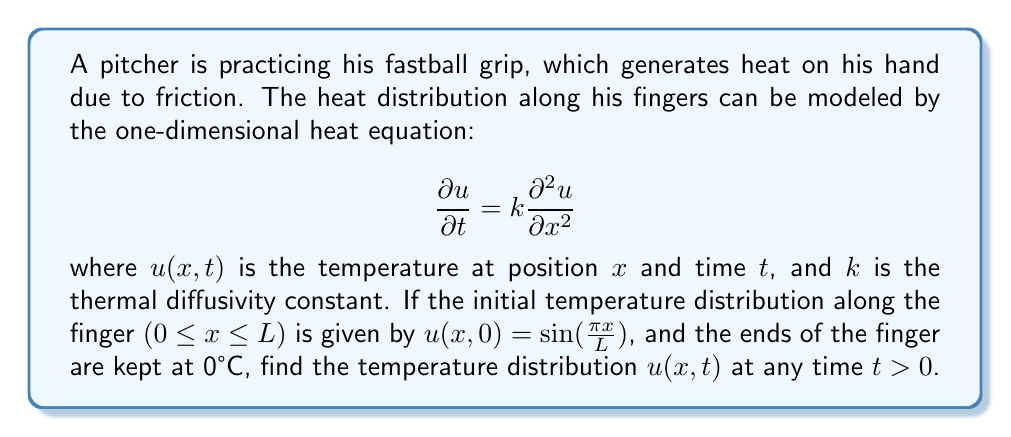Give your solution to this math problem. To solve this heat equation problem, we'll follow these steps:

1) The general solution for the heat equation with the given boundary conditions is:

   $$u(x,t) = \sum_{n=1}^{\infty} B_n \sin(\frac{n\pi x}{L}) e^{-k(\frac{n\pi}{L})^2t}$$

2) We need to find $B_n$ using the initial condition:

   $$u(x,0) = \sin(\frac{\pi x}{L}) = \sum_{n=1}^{\infty} B_n \sin(\frac{n\pi x}{L})$$

3) This is a Fourier sine series. For our initial condition, only the first term (n=1) matches, so:

   $$B_1 = 1$$
   $$B_n = 0 \text{ for } n > 1$$

4) Therefore, our solution simplifies to:

   $$u(x,t) = \sin(\frac{\pi x}{L}) e^{-k(\frac{\pi}{L})^2t}$$

This equation gives the temperature distribution along the pitcher's finger at any position x and time t.
Answer: $u(x,t) = \sin(\frac{\pi x}{L}) e^{-k(\frac{\pi}{L})^2t}$ 